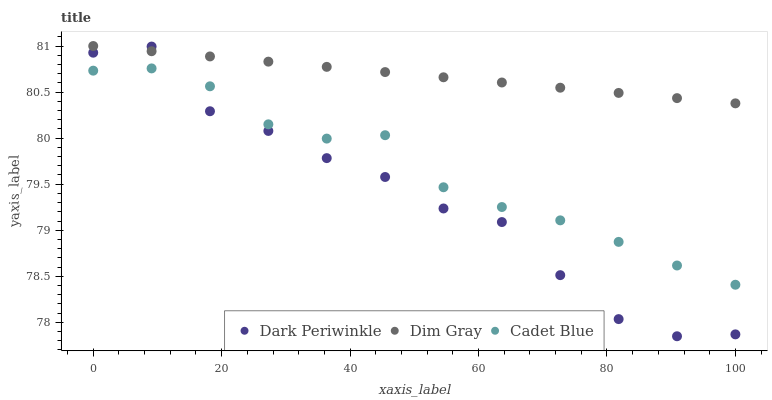Does Dark Periwinkle have the minimum area under the curve?
Answer yes or no. Yes. Does Dim Gray have the maximum area under the curve?
Answer yes or no. Yes. Does Dim Gray have the minimum area under the curve?
Answer yes or no. No. Does Dark Periwinkle have the maximum area under the curve?
Answer yes or no. No. Is Dim Gray the smoothest?
Answer yes or no. Yes. Is Dark Periwinkle the roughest?
Answer yes or no. Yes. Is Dark Periwinkle the smoothest?
Answer yes or no. No. Is Dim Gray the roughest?
Answer yes or no. No. Does Dark Periwinkle have the lowest value?
Answer yes or no. Yes. Does Dim Gray have the lowest value?
Answer yes or no. No. Does Dim Gray have the highest value?
Answer yes or no. Yes. Does Dark Periwinkle have the highest value?
Answer yes or no. No. Is Cadet Blue less than Dim Gray?
Answer yes or no. Yes. Is Dim Gray greater than Cadet Blue?
Answer yes or no. Yes. Does Dim Gray intersect Dark Periwinkle?
Answer yes or no. Yes. Is Dim Gray less than Dark Periwinkle?
Answer yes or no. No. Is Dim Gray greater than Dark Periwinkle?
Answer yes or no. No. Does Cadet Blue intersect Dim Gray?
Answer yes or no. No. 